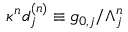<formula> <loc_0><loc_0><loc_500><loc_500>\kappa ^ { n } d _ { j } ^ { ( n ) } \equiv g _ { 0 , j } / \Lambda _ { j } ^ { n }</formula> 